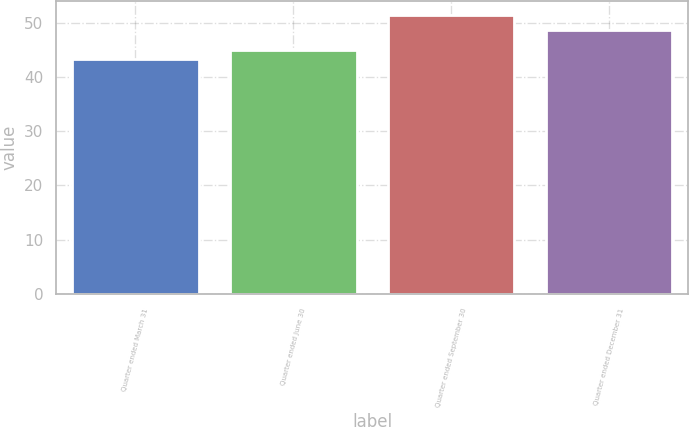Convert chart. <chart><loc_0><loc_0><loc_500><loc_500><bar_chart><fcel>Quarter ended March 31<fcel>Quarter ended June 30<fcel>Quarter ended September 30<fcel>Quarter ended December 31<nl><fcel>43.19<fcel>44.97<fcel>51.45<fcel>48.65<nl></chart> 